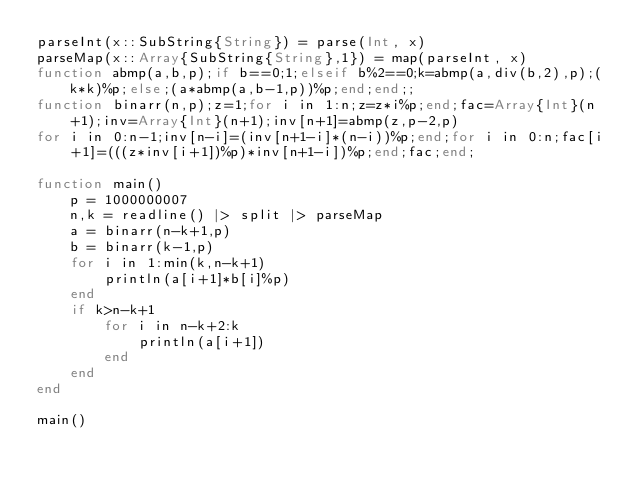<code> <loc_0><loc_0><loc_500><loc_500><_Julia_>parseInt(x::SubString{String}) = parse(Int, x)
parseMap(x::Array{SubString{String},1}) = map(parseInt, x)
function abmp(a,b,p);if b==0;1;elseif b%2==0;k=abmp(a,div(b,2),p);(k*k)%p;else;(a*abmp(a,b-1,p))%p;end;end;;
function binarr(n,p);z=1;for i in 1:n;z=z*i%p;end;fac=Array{Int}(n+1);inv=Array{Int}(n+1);inv[n+1]=abmp(z,p-2,p)
for i in 0:n-1;inv[n-i]=(inv[n+1-i]*(n-i))%p;end;for i in 0:n;fac[i+1]=(((z*inv[i+1])%p)*inv[n+1-i])%p;end;fac;end;

function main()
	p = 1000000007
	n,k = readline() |> split |> parseMap
	a = binarr(n-k+1,p)
	b = binarr(k-1,p)
	for i in 1:min(k,n-k+1)
		println(a[i+1]*b[i]%p)
	end
	if k>n-k+1
		for i in n-k+2:k
			println(a[i+1])
		end
	end
end

main()</code> 